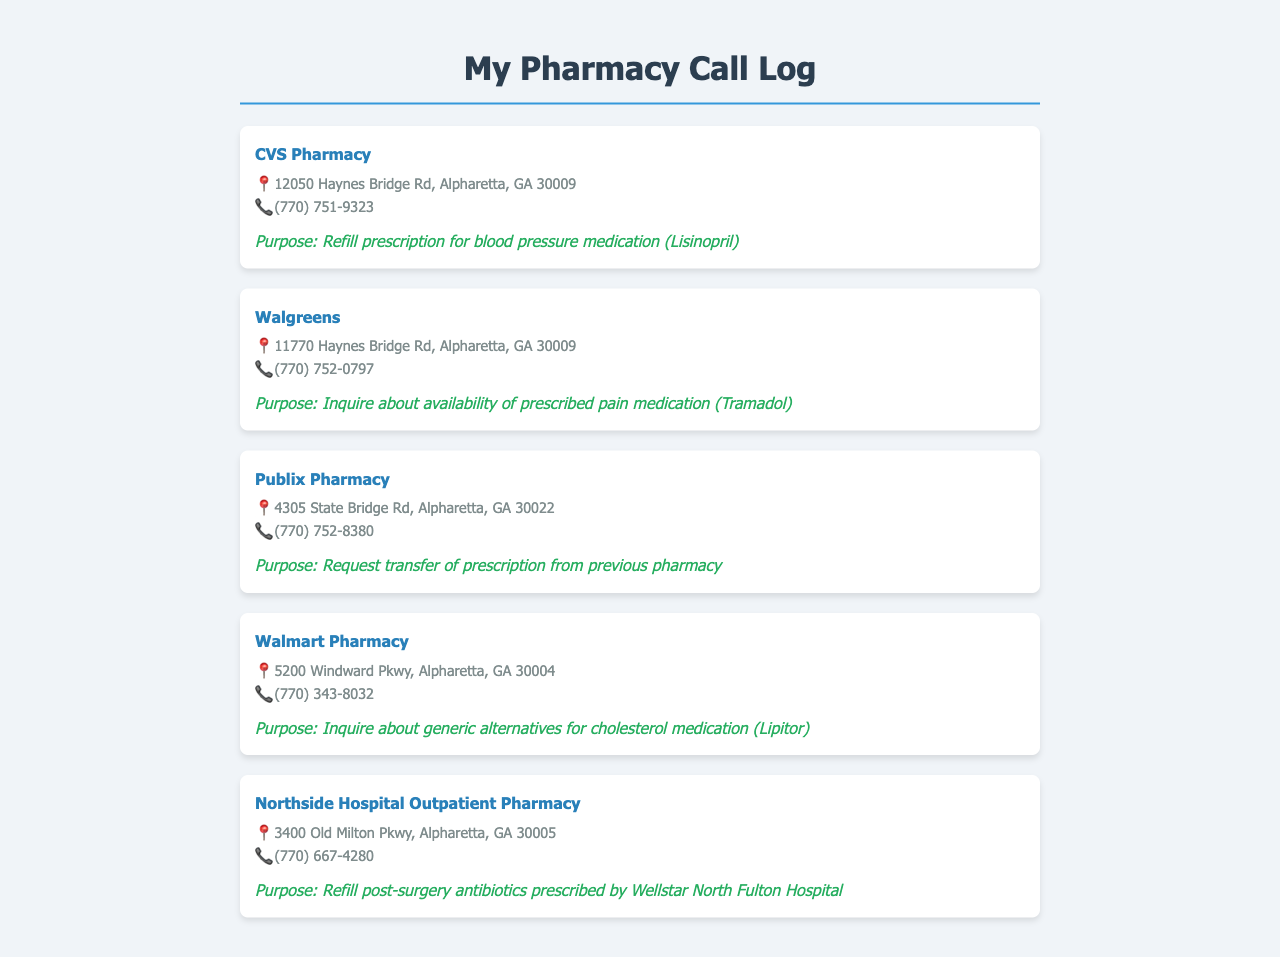What is the name of the first pharmacy listed? The first pharmacy listed in the document is CVS Pharmacy.
Answer: CVS Pharmacy What is the purpose of the call to Walgreens? The call to Walgreens was to inquire about the availability of prescribed pain medication (Tramadol).
Answer: Inquire about availability of prescribed pain medication (Tramadol) What is the address of Publix Pharmacy? The address of Publix Pharmacy is 4305 State Bridge Rd, Alpharetta, GA 30022.
Answer: 4305 State Bridge Rd, Alpharetta, GA 30022 How many pharmacies are listed in the call log? The document lists a total of five pharmacies.
Answer: Five What medication was requested to be refilled at Northside Hospital Outpatient Pharmacy? The medication requested to be refilled at Northside Hospital Outpatient Pharmacy was post-surgery antibiotics.
Answer: Post-surgery antibiotics What telephone number is associated with Walmart Pharmacy? The telephone number associated with Walmart Pharmacy is (770) 343-8032.
Answer: (770) 343-8032 Which pharmacy is closest to the given medication for blood pressure? The closest pharmacy for a blood pressure medication refill is CVS Pharmacy, as it is specifically mentioned for refilling Lisinopril.
Answer: CVS Pharmacy What type of medication was inquired about at Walmart Pharmacy? The type of medication inquired about at Walmart Pharmacy was for cholesterol (Lipitor).
Answer: Cholesterol medication (Lipitor) 